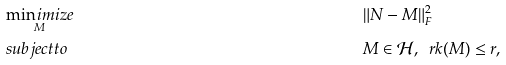Convert formula to latex. <formula><loc_0><loc_0><loc_500><loc_500>& \underset { M } { \min i m i z e } & & \| N - M \| _ { F } ^ { 2 } \\ & s u b j e c t t o & & M \in \mathcal { H } , \ \ r k ( M ) \leq r , \\</formula> 